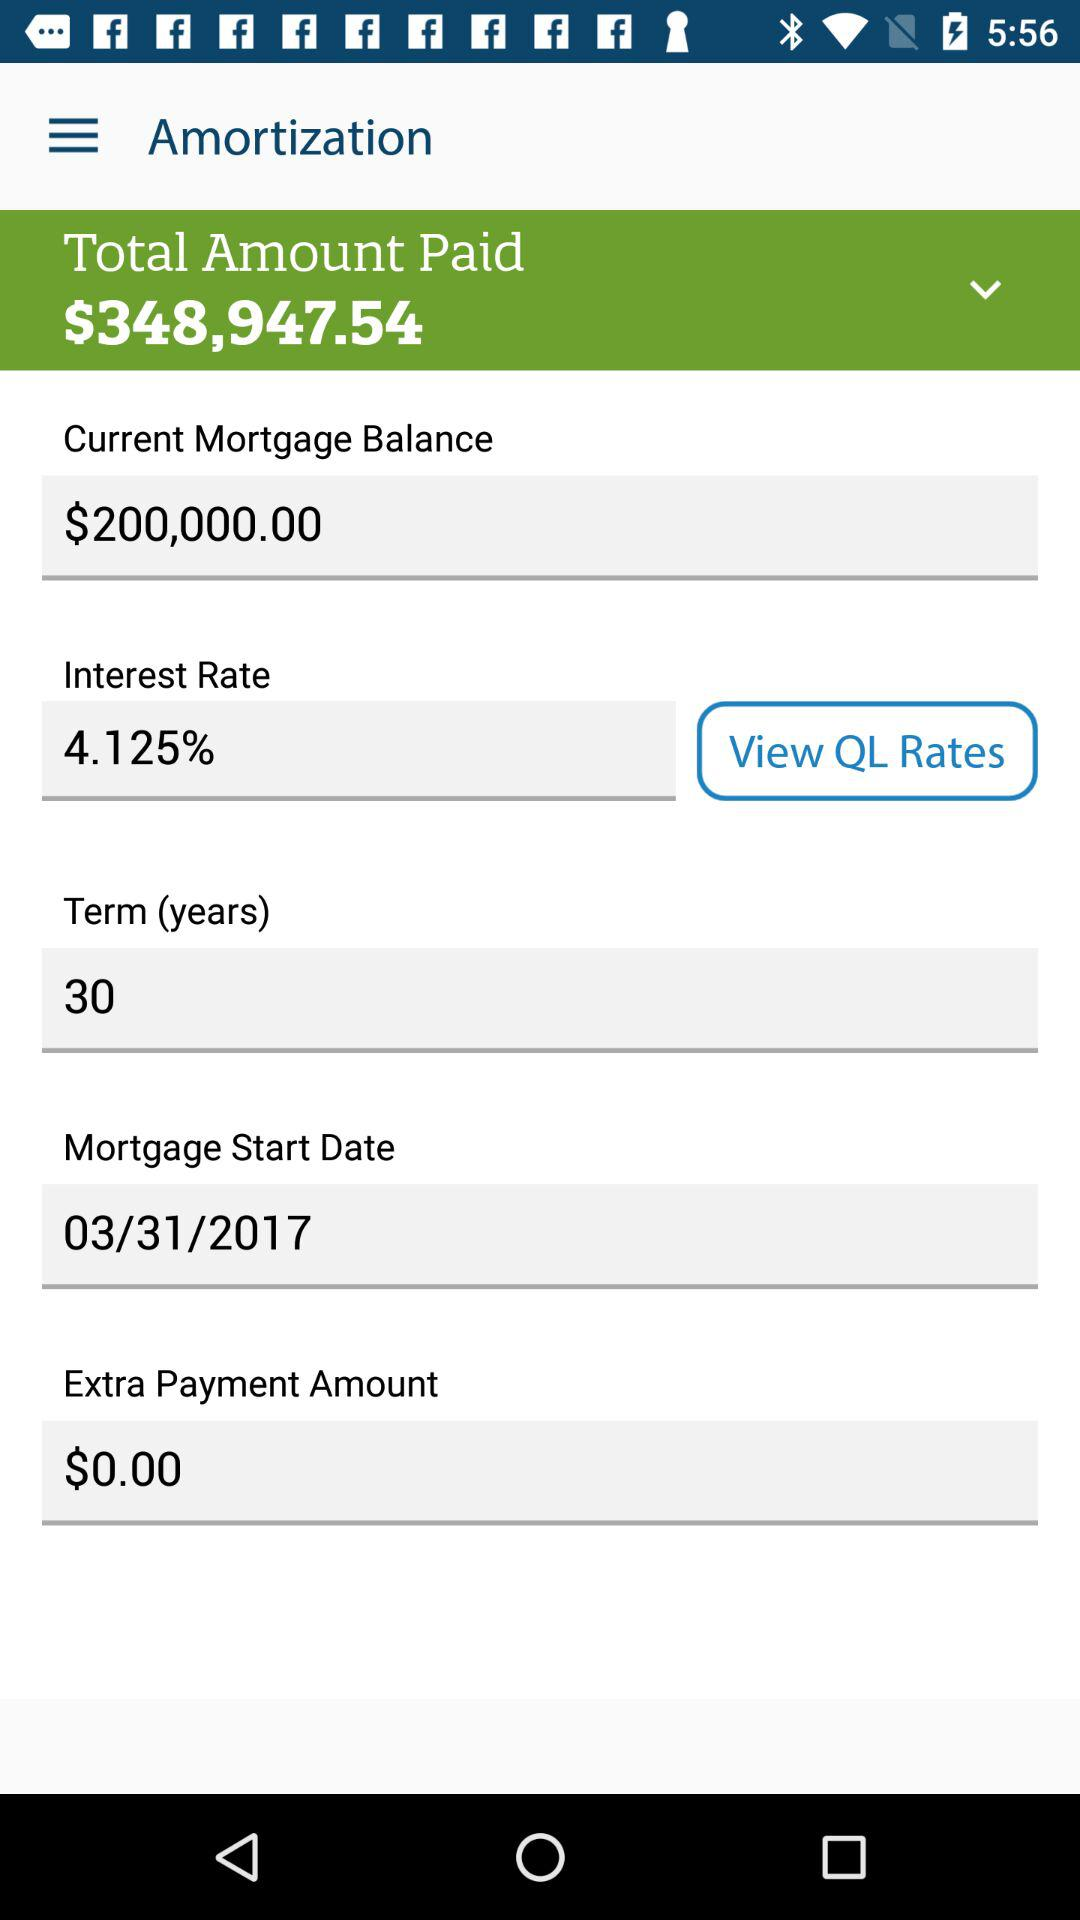What is the extra payment amount? The extra payment amount is $0.00. 